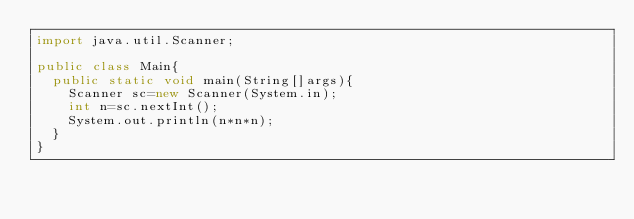Convert code to text. <code><loc_0><loc_0><loc_500><loc_500><_Java_>import java.util.Scanner;

public class Main{
  public static void main(String[]args){
    Scanner sc=new Scanner(System.in);
    int n=sc.nextInt();
    System.out.println(n*n*n);
  }
}</code> 